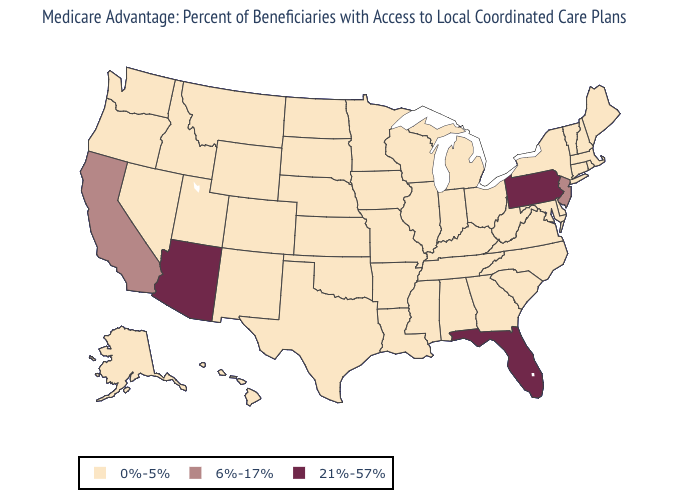Does the map have missing data?
Be succinct. No. What is the lowest value in the West?
Be succinct. 0%-5%. What is the value of Oklahoma?
Be succinct. 0%-5%. Name the states that have a value in the range 21%-57%?
Write a very short answer. Arizona, Florida, Pennsylvania. Among the states that border Kansas , which have the lowest value?
Quick response, please. Colorado, Missouri, Nebraska, Oklahoma. What is the lowest value in the Northeast?
Give a very brief answer. 0%-5%. Among the states that border Colorado , does New Mexico have the highest value?
Quick response, please. No. Which states hav the highest value in the Northeast?
Answer briefly. Pennsylvania. Among the states that border Oregon , which have the highest value?
Give a very brief answer. California. What is the highest value in the West ?
Quick response, please. 21%-57%. 